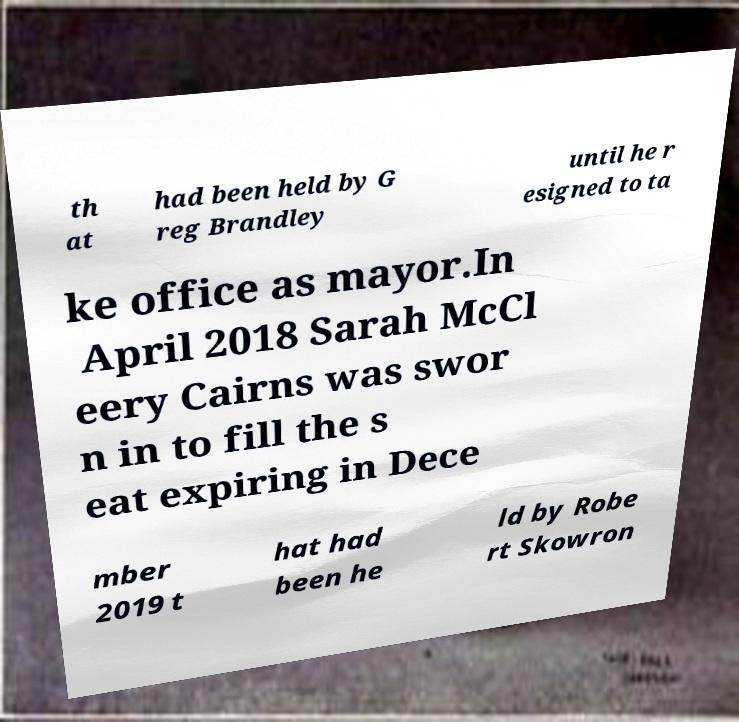For documentation purposes, I need the text within this image transcribed. Could you provide that? th at had been held by G reg Brandley until he r esigned to ta ke office as mayor.In April 2018 Sarah McCl eery Cairns was swor n in to fill the s eat expiring in Dece mber 2019 t hat had been he ld by Robe rt Skowron 